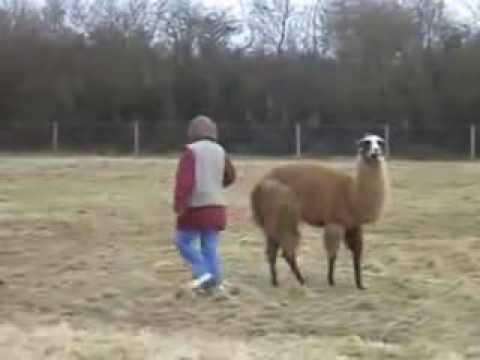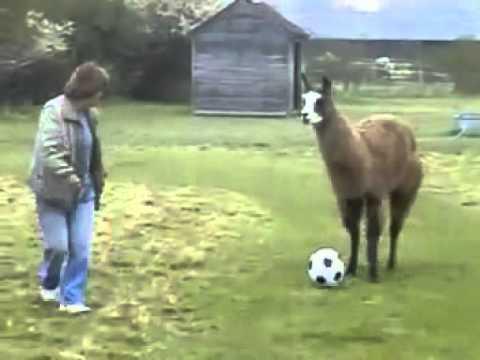The first image is the image on the left, the second image is the image on the right. Assess this claim about the two images: "One image shows a person in blue pants standing to the left of a brown llama, with a soccer ball on the ground between them.". Correct or not? Answer yes or no. Yes. The first image is the image on the left, the second image is the image on the right. Given the left and right images, does the statement "In one of the images, there is a soccer ball between a person and a llama." hold true? Answer yes or no. Yes. 